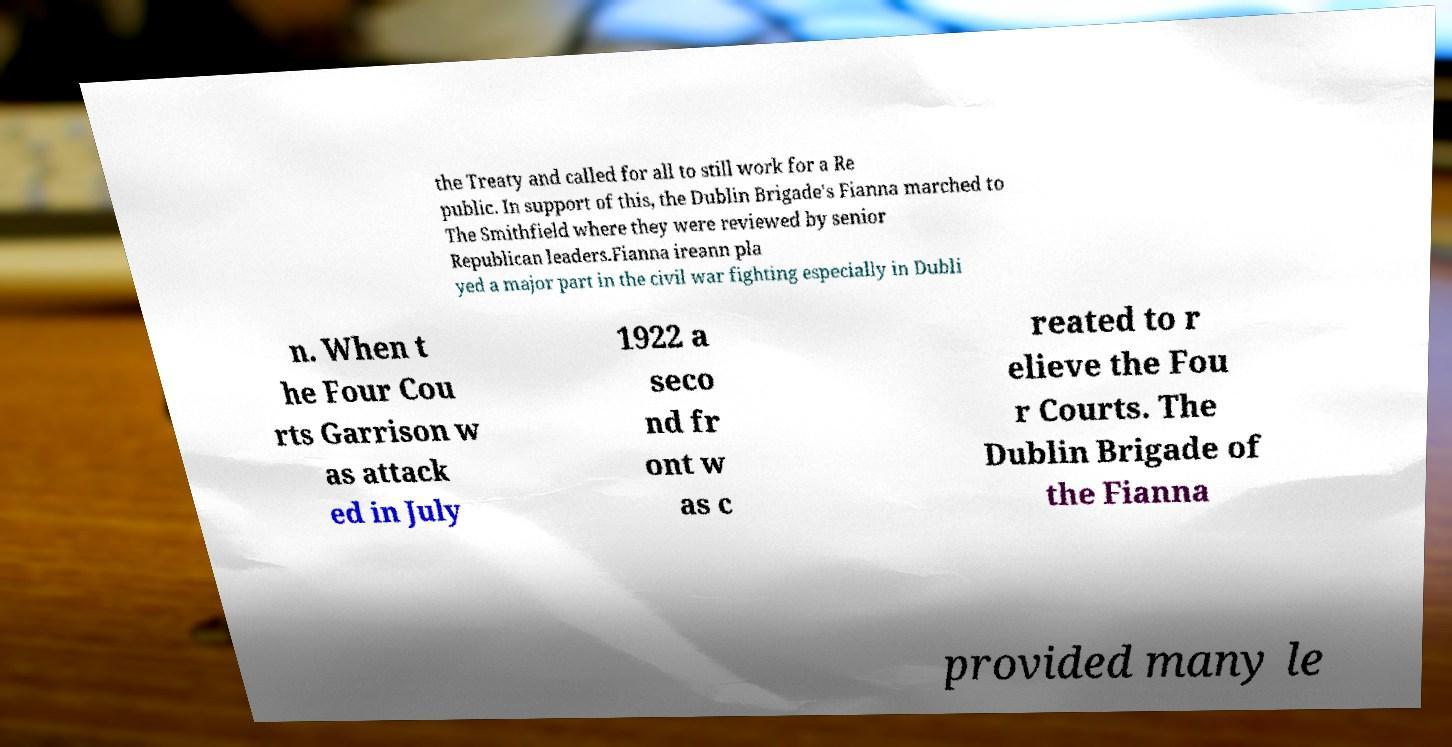What messages or text are displayed in this image? I need them in a readable, typed format. the Treaty and called for all to still work for a Re public. In support of this, the Dublin Brigade's Fianna marched to The Smithfield where they were reviewed by senior Republican leaders.Fianna ireann pla yed a major part in the civil war fighting especially in Dubli n. When t he Four Cou rts Garrison w as attack ed in July 1922 a seco nd fr ont w as c reated to r elieve the Fou r Courts. The Dublin Brigade of the Fianna provided many le 